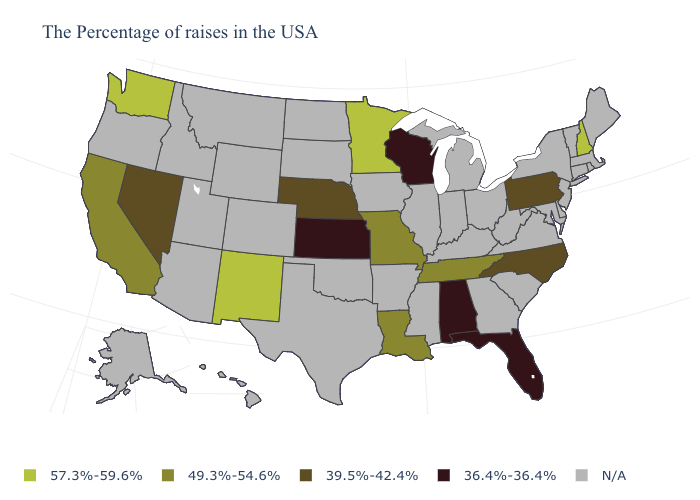Name the states that have a value in the range N/A?
Give a very brief answer. Maine, Massachusetts, Rhode Island, Vermont, Connecticut, New York, New Jersey, Delaware, Maryland, Virginia, South Carolina, West Virginia, Ohio, Georgia, Michigan, Kentucky, Indiana, Illinois, Mississippi, Arkansas, Iowa, Oklahoma, Texas, South Dakota, North Dakota, Wyoming, Colorado, Utah, Montana, Arizona, Idaho, Oregon, Alaska, Hawaii. What is the value of Louisiana?
Short answer required. 49.3%-54.6%. Does New Hampshire have the highest value in the Northeast?
Quick response, please. Yes. Which states hav the highest value in the MidWest?
Give a very brief answer. Minnesota. Does the first symbol in the legend represent the smallest category?
Quick response, please. No. Does Florida have the highest value in the USA?
Answer briefly. No. Name the states that have a value in the range 49.3%-54.6%?
Keep it brief. Tennessee, Louisiana, Missouri, California. Does the map have missing data?
Answer briefly. Yes. What is the value of Kentucky?
Write a very short answer. N/A. What is the value of Tennessee?
Concise answer only. 49.3%-54.6%. What is the value of Colorado?
Keep it brief. N/A. What is the highest value in the West ?
Quick response, please. 57.3%-59.6%. Does Florida have the lowest value in the USA?
Short answer required. Yes. Name the states that have a value in the range 36.4%-36.4%?
Short answer required. Florida, Alabama, Wisconsin, Kansas. 